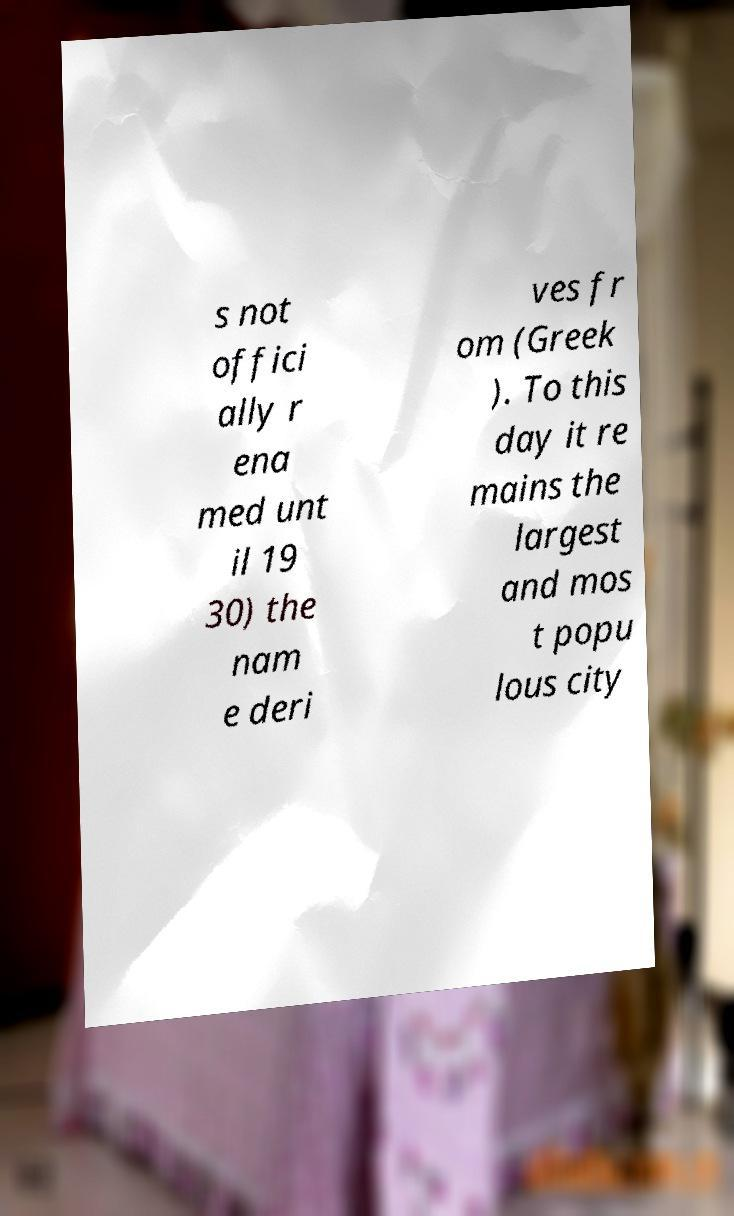For documentation purposes, I need the text within this image transcribed. Could you provide that? s not offici ally r ena med unt il 19 30) the nam e deri ves fr om (Greek ). To this day it re mains the largest and mos t popu lous city 